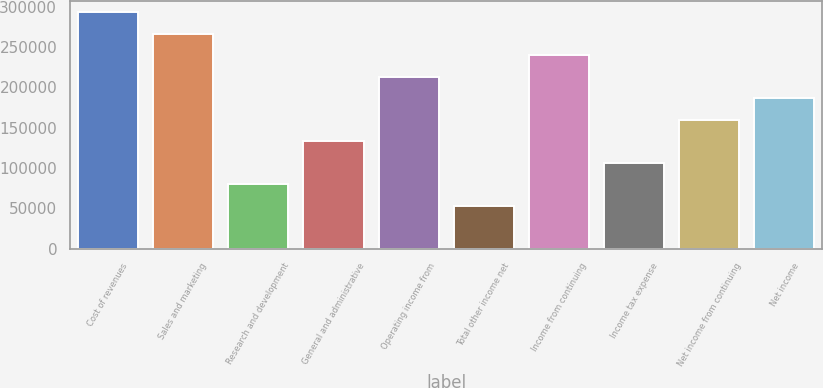<chart> <loc_0><loc_0><loc_500><loc_500><bar_chart><fcel>Cost of revenues<fcel>Sales and marketing<fcel>Research and development<fcel>General and administrative<fcel>Operating income from<fcel>Total other income net<fcel>Income from continuing<fcel>Income tax expense<fcel>Net income from continuing<fcel>Net income<nl><fcel>292687<fcel>266079<fcel>79823.7<fcel>133040<fcel>212863<fcel>53215.8<fcel>239471<fcel>106432<fcel>159647<fcel>186255<nl></chart> 